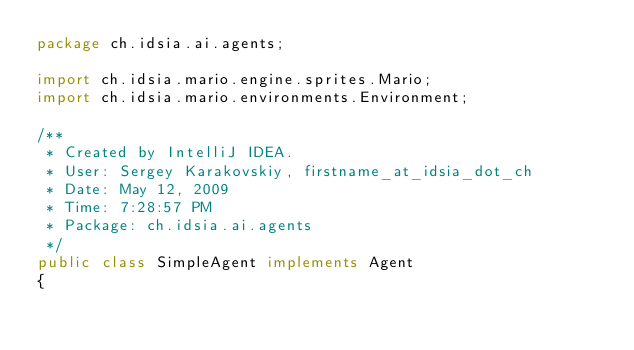<code> <loc_0><loc_0><loc_500><loc_500><_Java_>package ch.idsia.ai.agents;

import ch.idsia.mario.engine.sprites.Mario;
import ch.idsia.mario.environments.Environment;

/**
 * Created by IntelliJ IDEA.
 * User: Sergey Karakovskiy, firstname_at_idsia_dot_ch
 * Date: May 12, 2009
 * Time: 7:28:57 PM
 * Package: ch.idsia.ai.agents
 */
public class SimpleAgent implements Agent
{</code> 